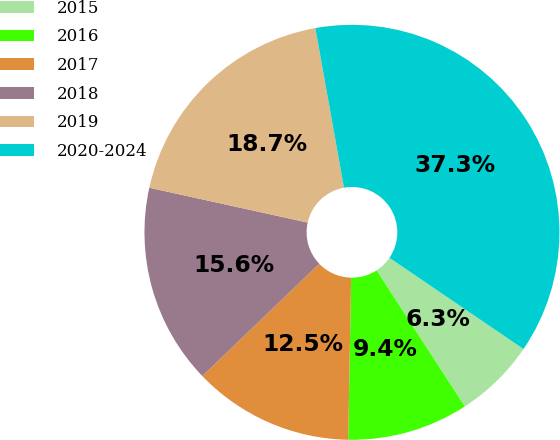<chart> <loc_0><loc_0><loc_500><loc_500><pie_chart><fcel>2015<fcel>2016<fcel>2017<fcel>2018<fcel>2019<fcel>2020-2024<nl><fcel>6.34%<fcel>9.44%<fcel>12.53%<fcel>15.63%<fcel>18.73%<fcel>37.33%<nl></chart> 